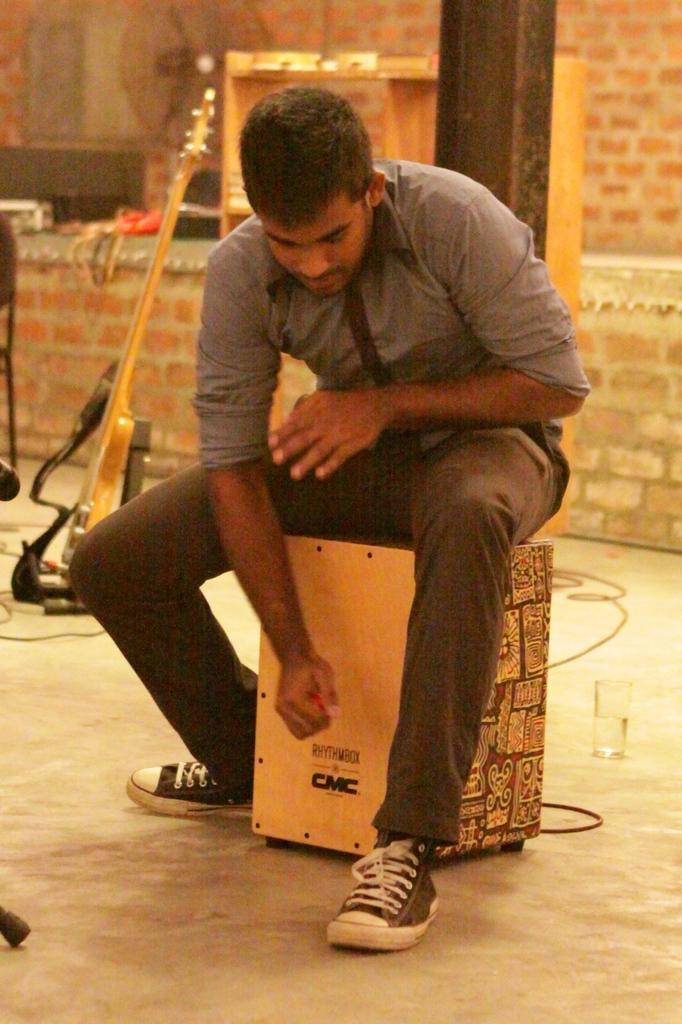How would you summarize this image in a sentence or two? In the center of the image we can see a man is sitting on a wood. In the background of the image we can see the wall, pole, rack, guitar. On the rack, we can see some objects. At the bottom of the image we can see the floor, wires and glass. 